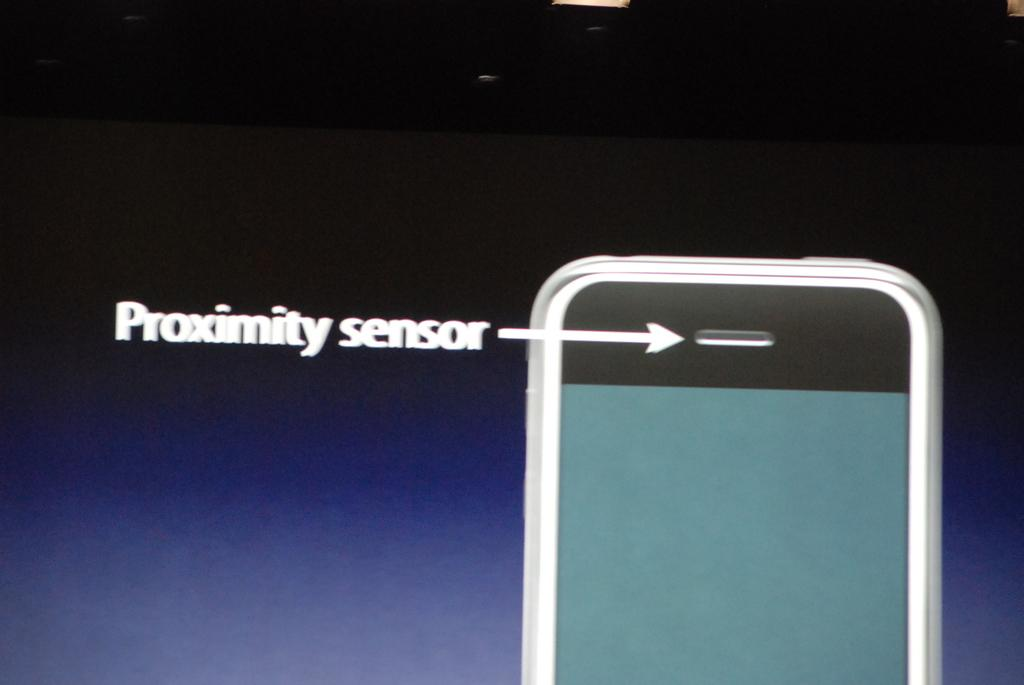<image>
Share a concise interpretation of the image provided. a phone with the word sensor at the top of it 